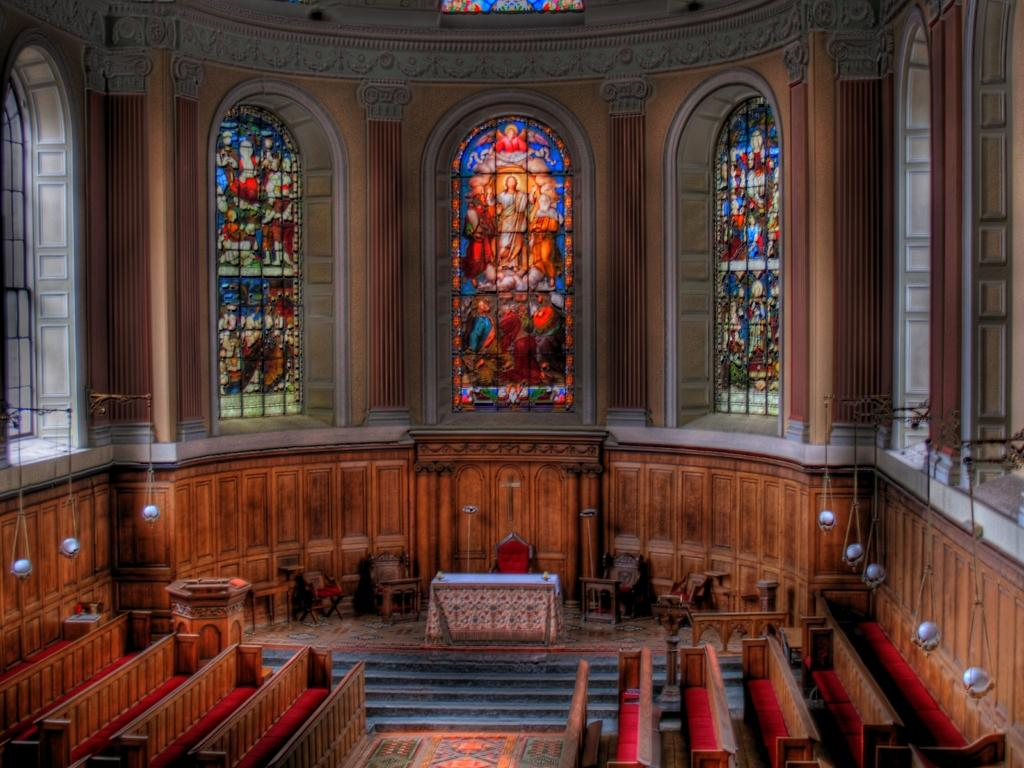What type of location is depicted in the image? The image is an inside view of a building. What type of furniture is present in the image? There are benches, chairs, and tables in the image. What other objects can be seen in the image? There are various objects in the image. What architectural features are visible in the image? There are windows and walls in the image. What design elements can be observed on the windows? There are designs on the window glasses. What is causing the person in the image to feel angry? There is no person present in the image, and therefore no emotion can be attributed to anyone. Can you see any steam coming from the objects in the image? There is no steam present in the image. 